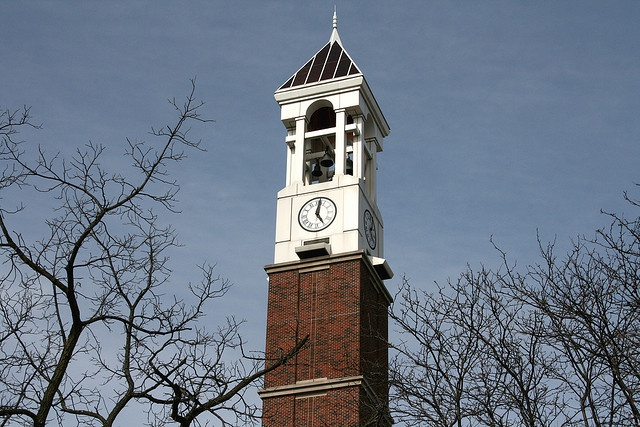Describe the objects in this image and their specific colors. I can see clock in gray, white, darkgray, and black tones and clock in gray, black, and purple tones in this image. 